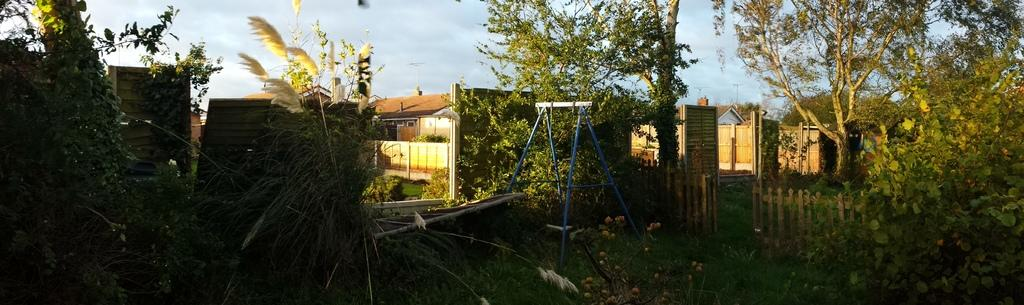What type of structures can be seen in the image? There are sheds in the image. What type of vegetation is present in the image? There are trees and plants in the image. What type of barrier can be seen in the image? There is a fence in the image. What type of support structure is present in the image? There is a stand in the image. What can be seen in the background of the image? A: There are poles in the background of the image. What is visible at the top of the image? The sky is visible at the top of the image. What degree of pain is the person experiencing in the image? There is no person present in the image, so it is not possible to determine their level of pain. How can someone help the person in the image? There is no person present in the image, so it is not possible to provide assistance. 